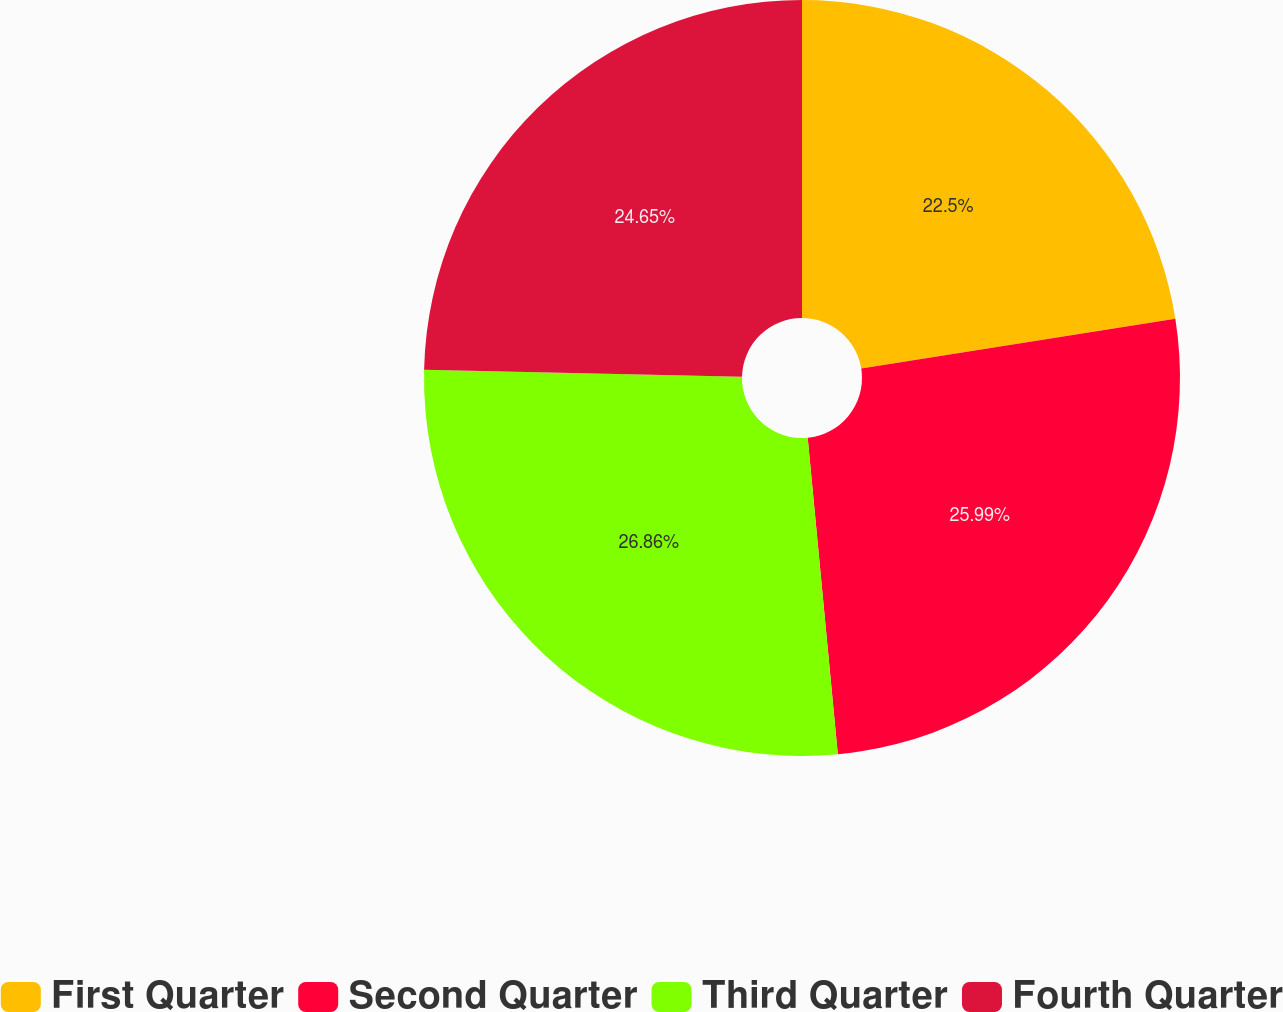Convert chart to OTSL. <chart><loc_0><loc_0><loc_500><loc_500><pie_chart><fcel>First Quarter<fcel>Second Quarter<fcel>Third Quarter<fcel>Fourth Quarter<nl><fcel>22.5%<fcel>25.99%<fcel>26.86%<fcel>24.65%<nl></chart> 